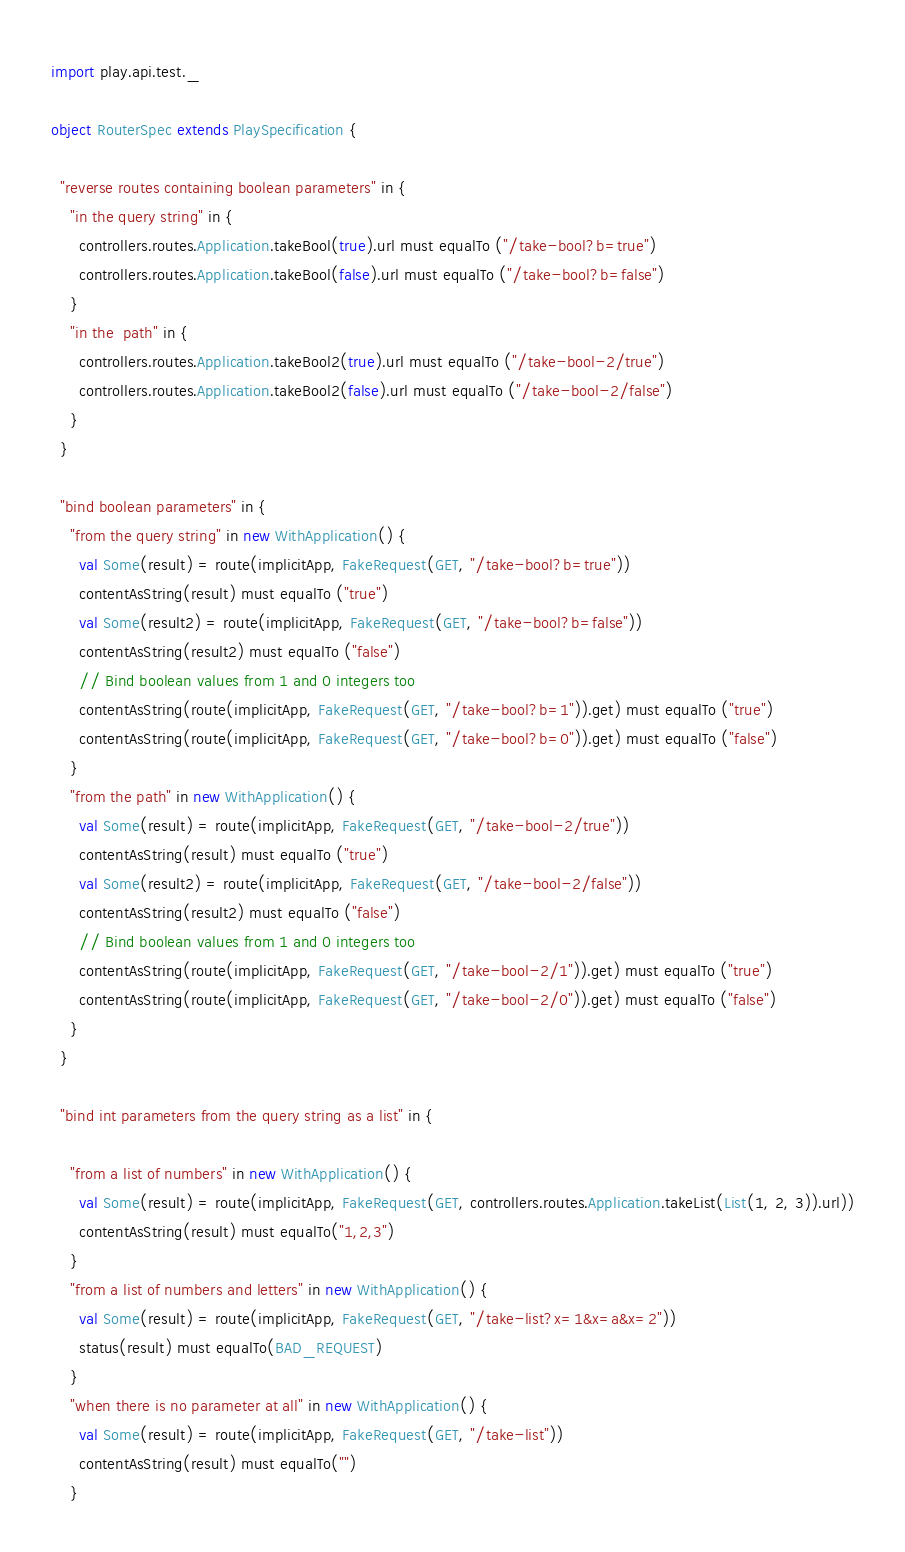Convert code to text. <code><loc_0><loc_0><loc_500><loc_500><_Scala_>
import play.api.test._

object RouterSpec extends PlaySpecification {

  "reverse routes containing boolean parameters" in {
    "in the query string" in {
      controllers.routes.Application.takeBool(true).url must equalTo ("/take-bool?b=true")
      controllers.routes.Application.takeBool(false).url must equalTo ("/take-bool?b=false")
    }
    "in the  path" in {
      controllers.routes.Application.takeBool2(true).url must equalTo ("/take-bool-2/true")
      controllers.routes.Application.takeBool2(false).url must equalTo ("/take-bool-2/false")
    }
  }

  "bind boolean parameters" in {
    "from the query string" in new WithApplication() { 
      val Some(result) = route(implicitApp, FakeRequest(GET, "/take-bool?b=true"))
      contentAsString(result) must equalTo ("true")
      val Some(result2) = route(implicitApp, FakeRequest(GET, "/take-bool?b=false"))
      contentAsString(result2) must equalTo ("false")
      // Bind boolean values from 1 and 0 integers too
      contentAsString(route(implicitApp, FakeRequest(GET, "/take-bool?b=1")).get) must equalTo ("true")
      contentAsString(route(implicitApp, FakeRequest(GET, "/take-bool?b=0")).get) must equalTo ("false")
    }
    "from the path" in new WithApplication() { 
      val Some(result) = route(implicitApp, FakeRequest(GET, "/take-bool-2/true"))
      contentAsString(result) must equalTo ("true")
      val Some(result2) = route(implicitApp, FakeRequest(GET, "/take-bool-2/false"))
      contentAsString(result2) must equalTo ("false")
      // Bind boolean values from 1 and 0 integers too
      contentAsString(route(implicitApp, FakeRequest(GET, "/take-bool-2/1")).get) must equalTo ("true")
      contentAsString(route(implicitApp, FakeRequest(GET, "/take-bool-2/0")).get) must equalTo ("false")
    }
  }

  "bind int parameters from the query string as a list" in {

    "from a list of numbers" in new WithApplication() { 
      val Some(result) = route(implicitApp, FakeRequest(GET, controllers.routes.Application.takeList(List(1, 2, 3)).url))
      contentAsString(result) must equalTo("1,2,3")
    }
    "from a list of numbers and letters" in new WithApplication() { 
      val Some(result) = route(implicitApp, FakeRequest(GET, "/take-list?x=1&x=a&x=2"))
      status(result) must equalTo(BAD_REQUEST)
    }
    "when there is no parameter at all" in new WithApplication() { 
      val Some(result) = route(implicitApp, FakeRequest(GET, "/take-list"))
      contentAsString(result) must equalTo("")
    }</code> 